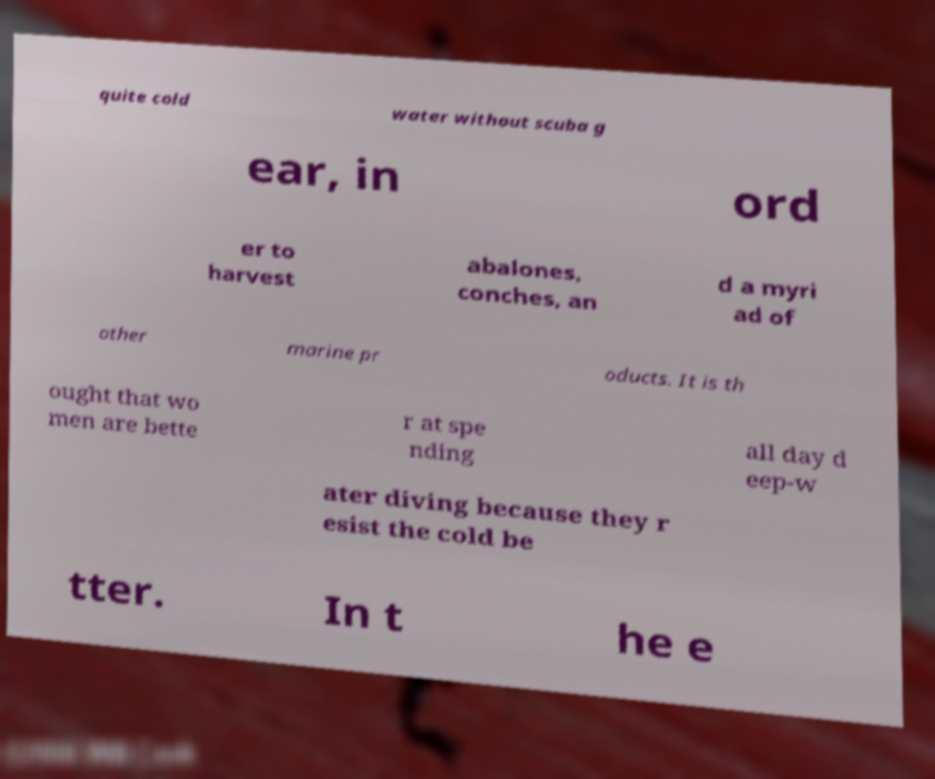There's text embedded in this image that I need extracted. Can you transcribe it verbatim? quite cold water without scuba g ear, in ord er to harvest abalones, conches, an d a myri ad of other marine pr oducts. It is th ought that wo men are bette r at spe nding all day d eep-w ater diving because they r esist the cold be tter. In t he e 